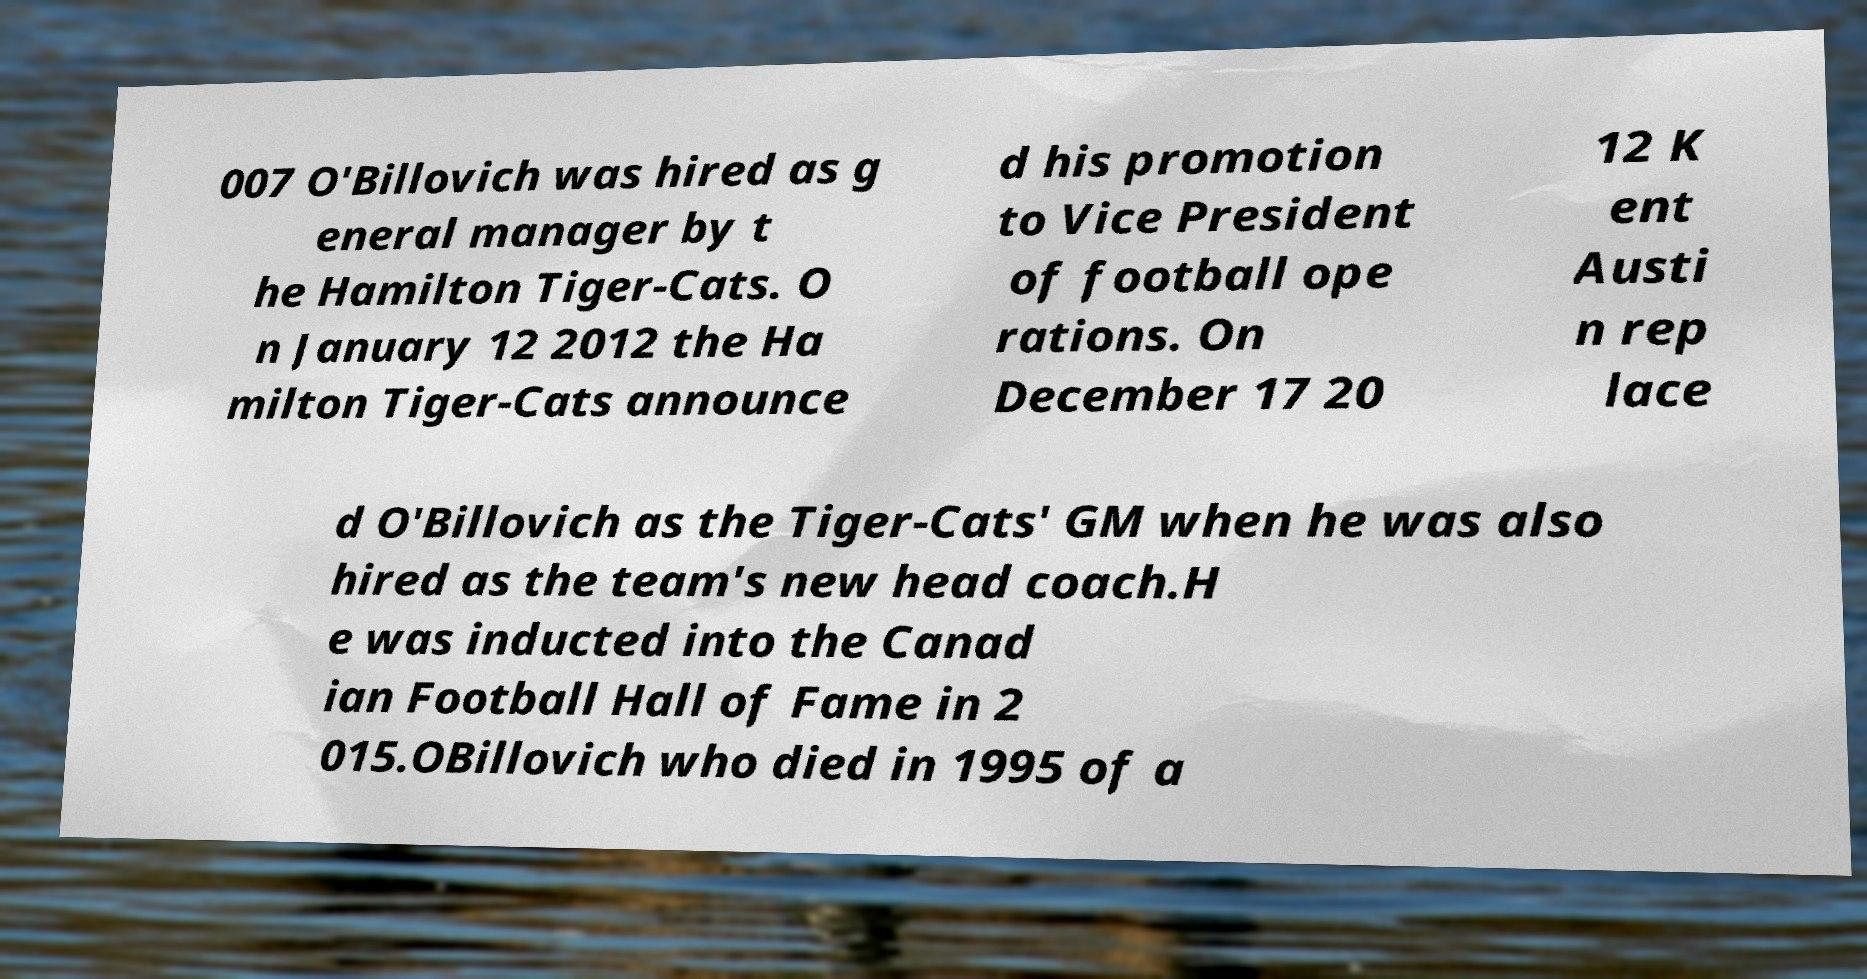Could you assist in decoding the text presented in this image and type it out clearly? 007 O'Billovich was hired as g eneral manager by t he Hamilton Tiger-Cats. O n January 12 2012 the Ha milton Tiger-Cats announce d his promotion to Vice President of football ope rations. On December 17 20 12 K ent Austi n rep lace d O'Billovich as the Tiger-Cats' GM when he was also hired as the team's new head coach.H e was inducted into the Canad ian Football Hall of Fame in 2 015.OBillovich who died in 1995 of a 